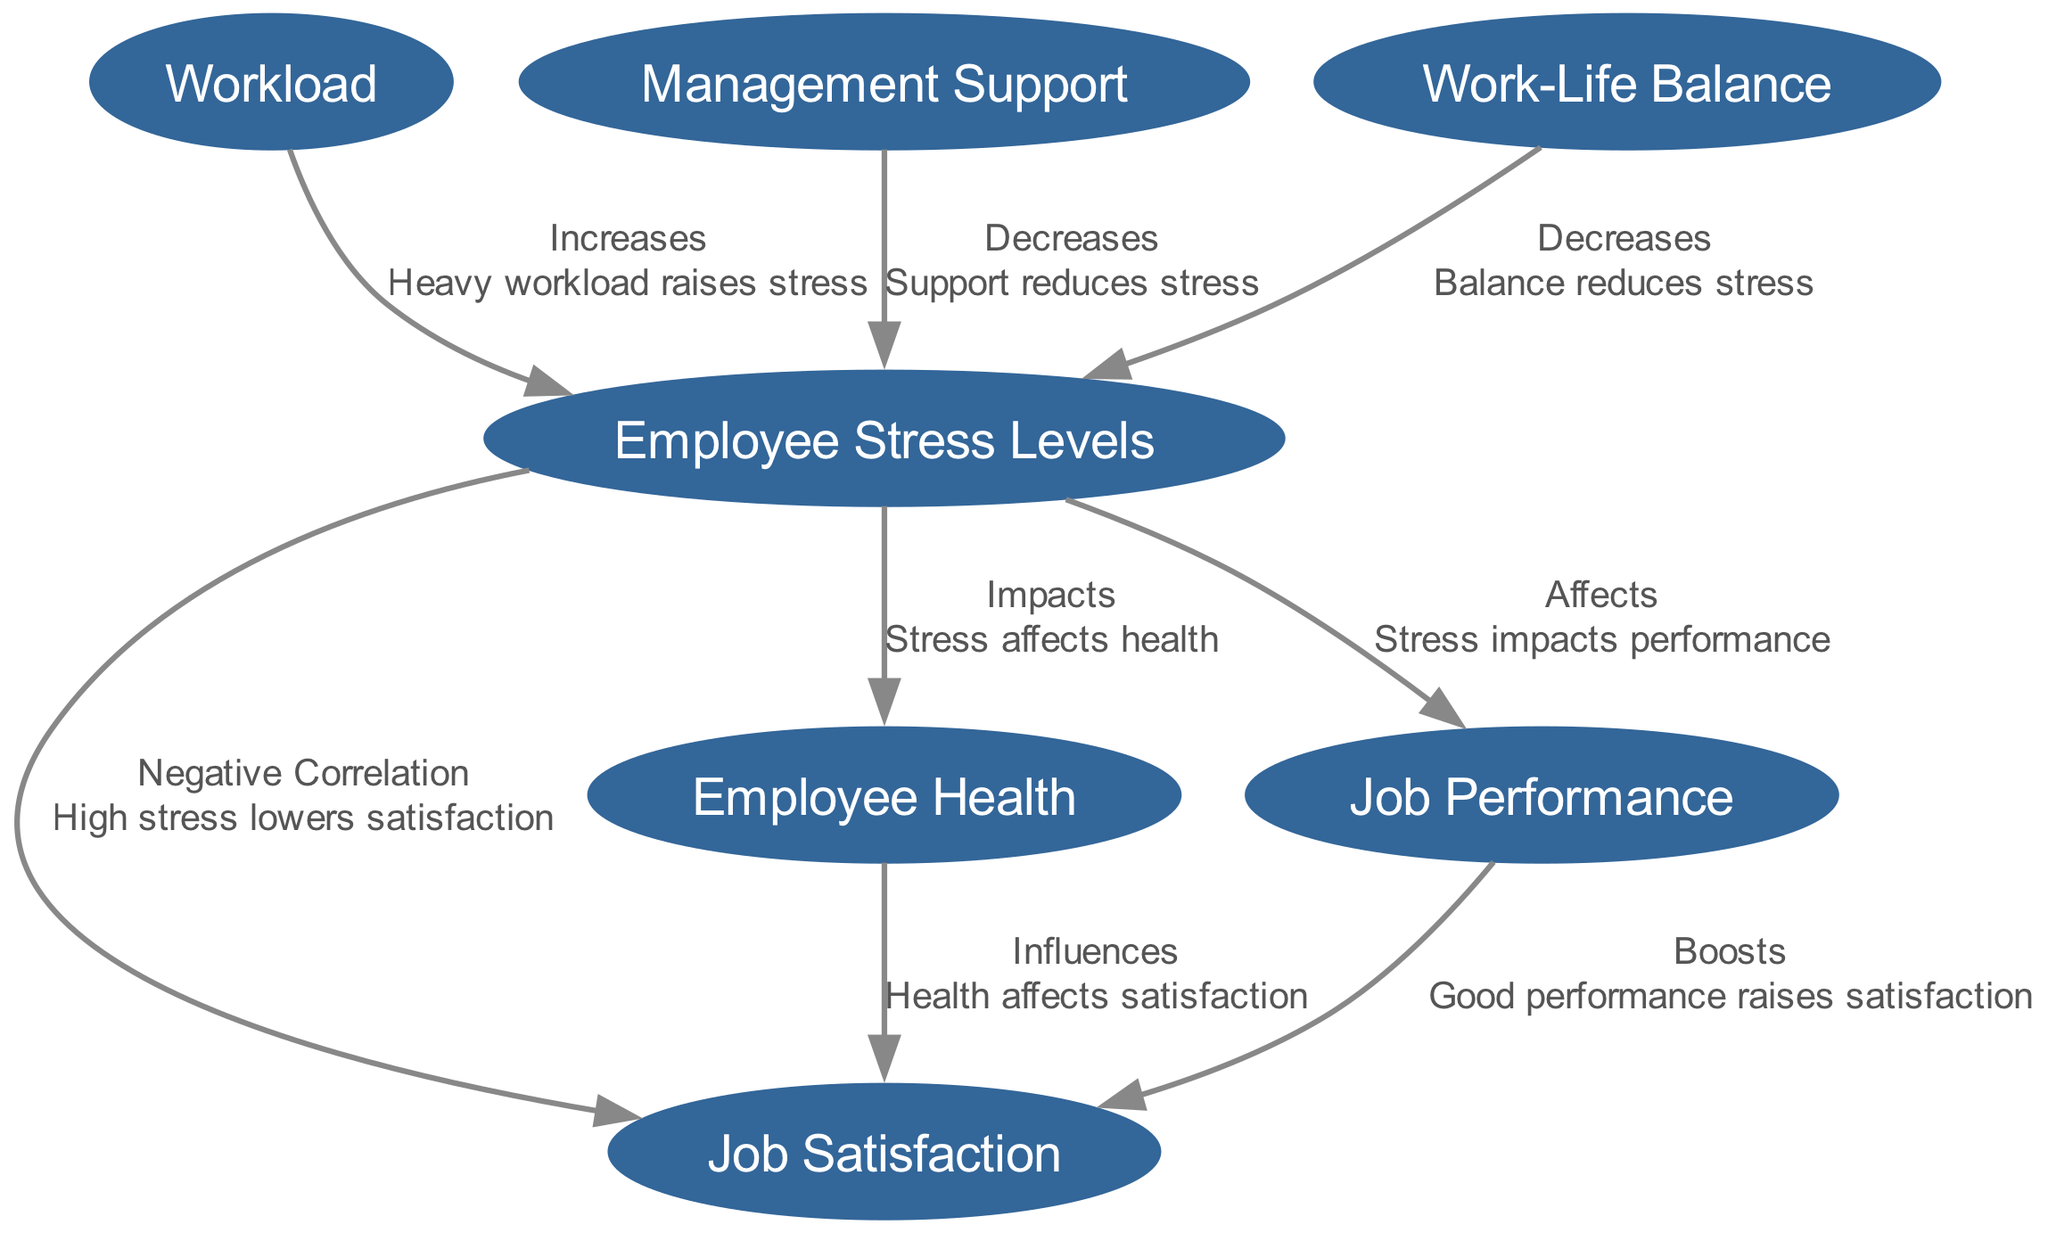What is the relationship between Employee Stress Levels and Job Satisfaction? The diagram shows a negative correlation between Employee Stress Levels and Job Satisfaction, indicating that high stress lowers satisfaction.
Answer: Negative Correlation How many nodes are present in this diagram? The diagram contains a total of seven nodes, each representing different factors related to stress and job satisfaction.
Answer: 7 Which factor decreases Employee Stress Levels according to the diagram? The diagram identifies Management Support and Work-Life Balance as factors that decrease Employee Stress Levels.
Answer: Management Support, Work-Life Balance What influences Job Satisfaction according to Employee Health? The diagram shows that Employee Health influences Job Satisfaction, meaning that health affects satisfaction levels.
Answer: Employee Health How does Heavy Workload affect Employee Stress Levels? The diagram indicates that Heavy Workload increases Employee Stress Levels, thereby contributing to heightened stress among employees.
Answer: Increases What effect does Employee Stress have on Job Performance? According to the diagram, Employee Stress impacts Job Performance, which means that higher stress negatively affects performance.
Answer: Affects How do good Job Performance levels relate to Job Satisfaction? The diagram states that good Job Performance boosts Job Satisfaction, indicating that higher performance leads to greater satisfaction at work.
Answer: Boosts What is the relationship between Management Support and Employee Stress Levels? The diagram illustrates that Management Support decreases Employee Stress Levels, meaning that having support reduces stress experienced by employees.
Answer: Decreases 